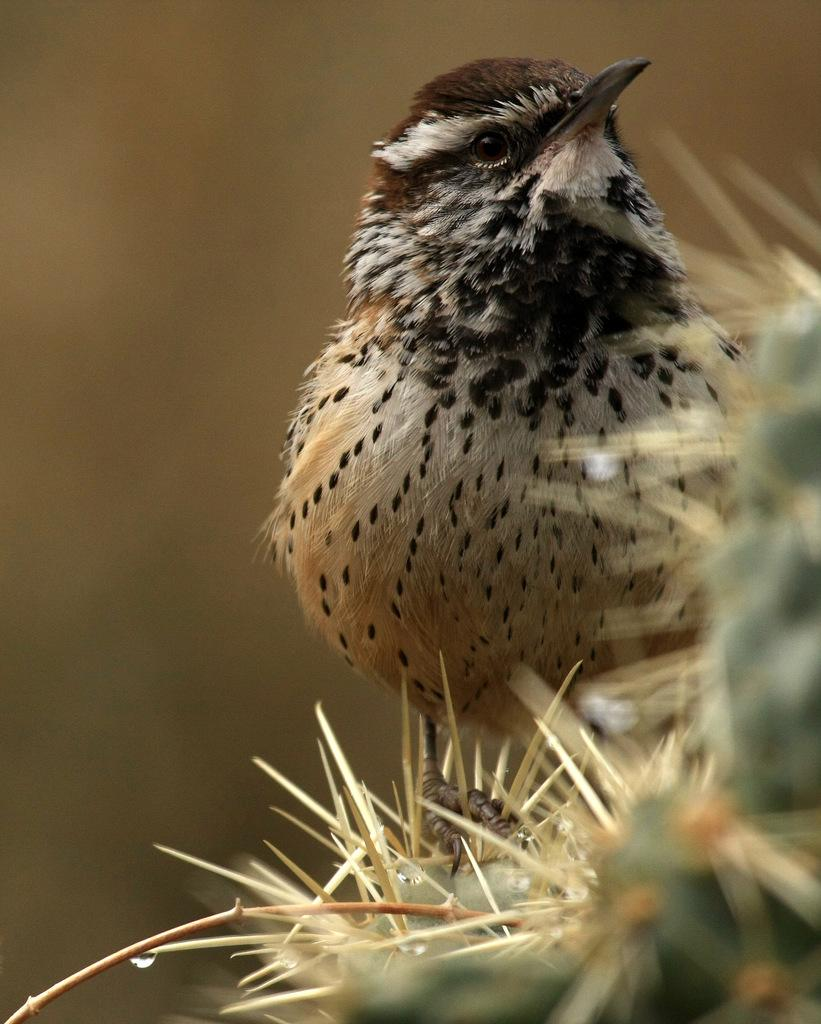What type of animal is in the image? There is a bird in the image. Can you describe the bird's colors? The bird has brown and black colors. What can be observed about the background of the image? The background of the image is blurred. What type of crate is visible in the image? There is no crate present in the image. Can you describe the bird's habitat in the image? The bird's habitat cannot be definitively determined from the image, as the background is blurred. 